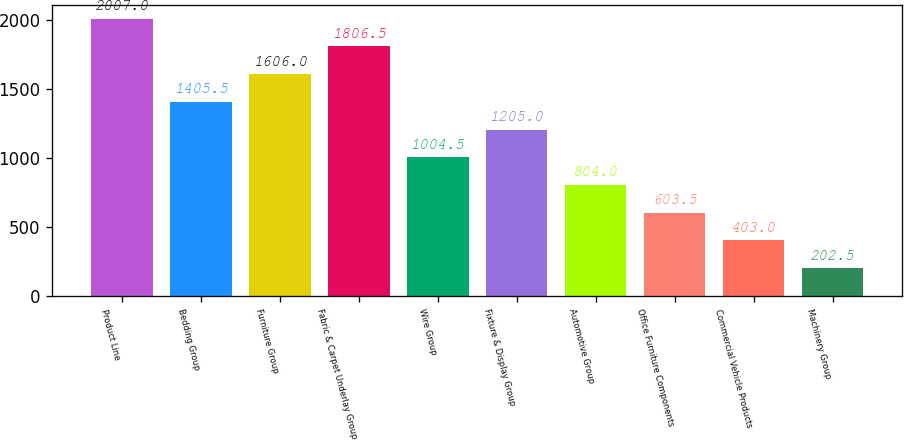Convert chart. <chart><loc_0><loc_0><loc_500><loc_500><bar_chart><fcel>Product Line<fcel>Bedding Group<fcel>Furniture Group<fcel>Fabric & Carpet Underlay Group<fcel>Wire Group<fcel>Fixture & Display Group<fcel>Automotive Group<fcel>Office Furniture Components<fcel>Commercial Vehicle Products<fcel>Machinery Group<nl><fcel>2007<fcel>1405.5<fcel>1606<fcel>1806.5<fcel>1004.5<fcel>1205<fcel>804<fcel>603.5<fcel>403<fcel>202.5<nl></chart> 